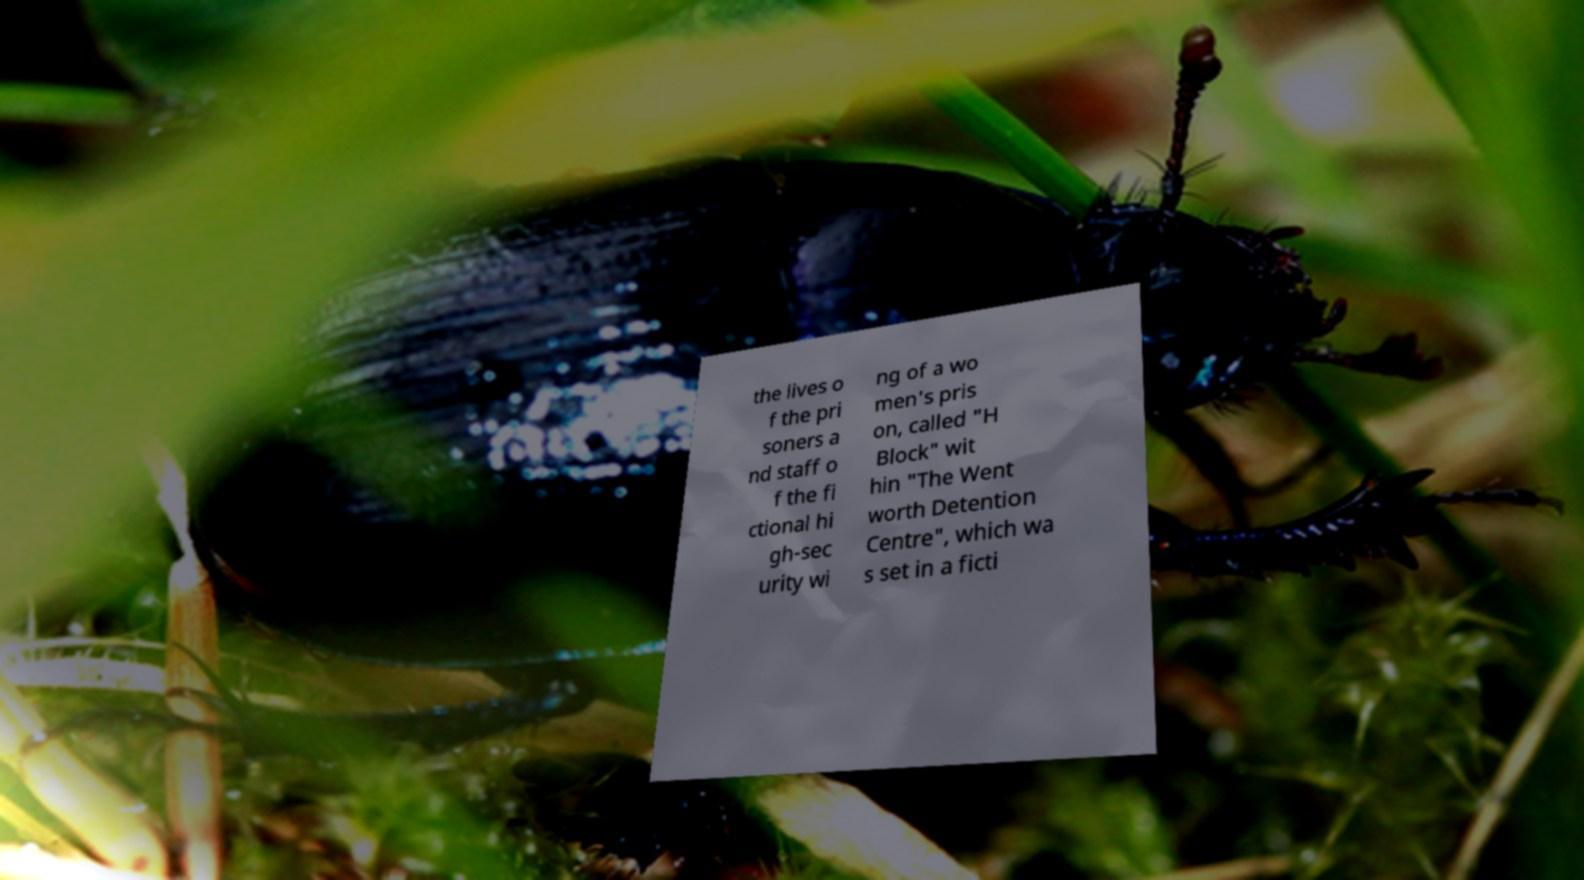Please read and relay the text visible in this image. What does it say? the lives o f the pri soners a nd staff o f the fi ctional hi gh-sec urity wi ng of a wo men's pris on, called "H Block" wit hin "The Went worth Detention Centre", which wa s set in a ficti 